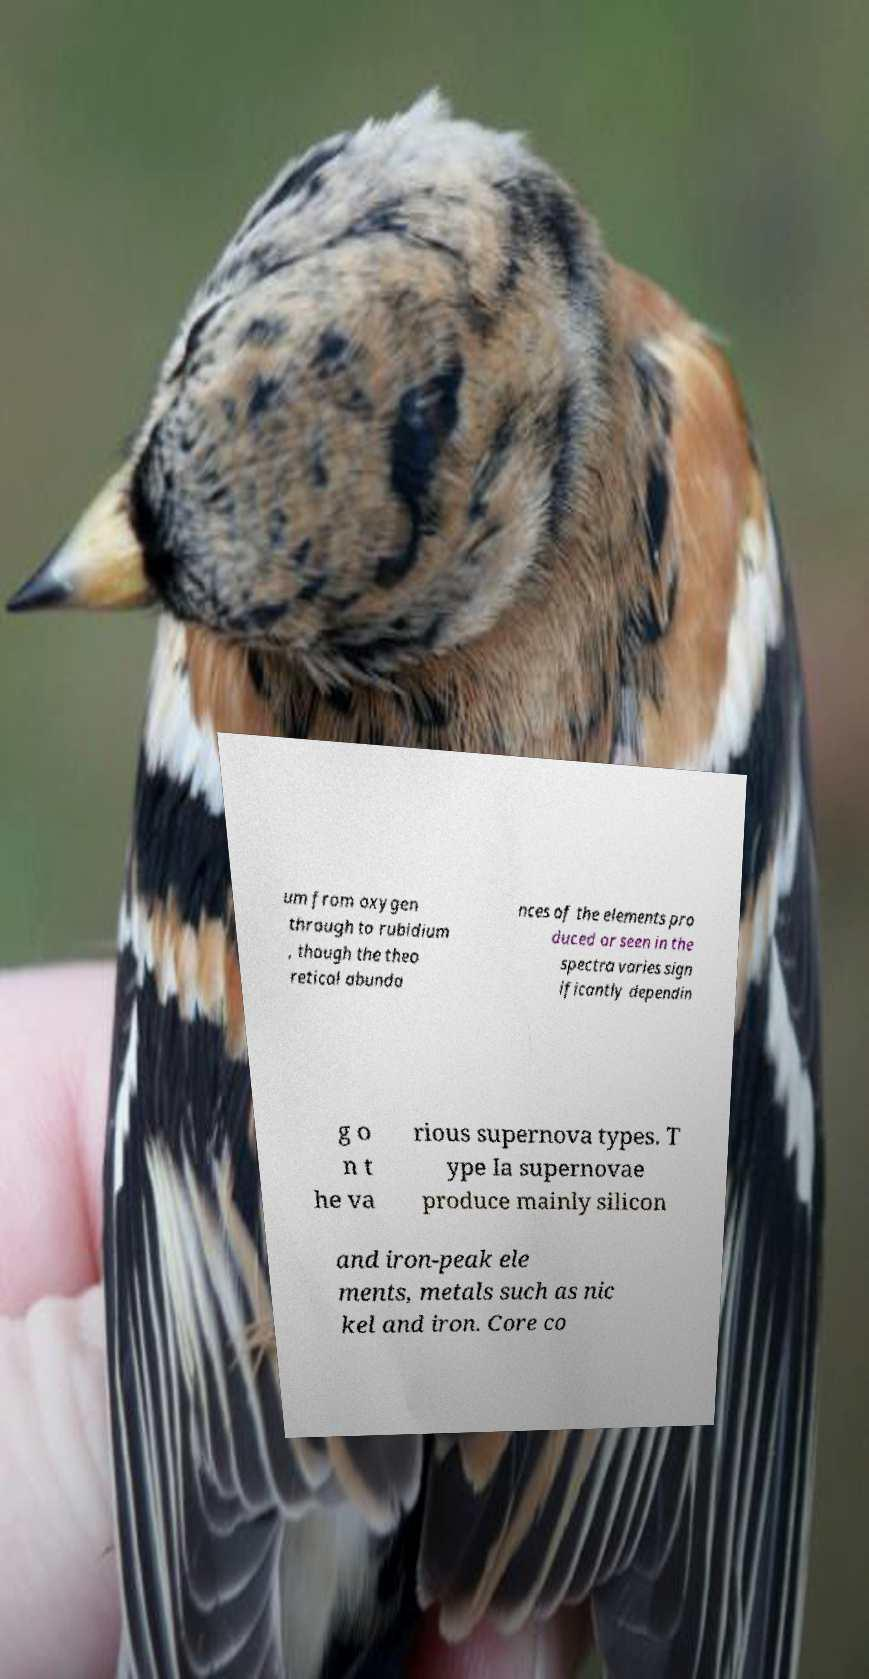Please identify and transcribe the text found in this image. um from oxygen through to rubidium , though the theo retical abunda nces of the elements pro duced or seen in the spectra varies sign ificantly dependin g o n t he va rious supernova types. T ype Ia supernovae produce mainly silicon and iron-peak ele ments, metals such as nic kel and iron. Core co 